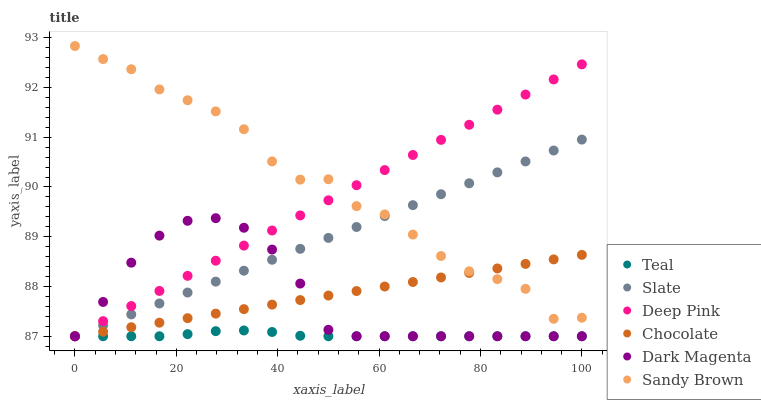Does Teal have the minimum area under the curve?
Answer yes or no. Yes. Does Sandy Brown have the maximum area under the curve?
Answer yes or no. Yes. Does Dark Magenta have the minimum area under the curve?
Answer yes or no. No. Does Dark Magenta have the maximum area under the curve?
Answer yes or no. No. Is Chocolate the smoothest?
Answer yes or no. Yes. Is Sandy Brown the roughest?
Answer yes or no. Yes. Is Dark Magenta the smoothest?
Answer yes or no. No. Is Dark Magenta the roughest?
Answer yes or no. No. Does Deep Pink have the lowest value?
Answer yes or no. Yes. Does Sandy Brown have the lowest value?
Answer yes or no. No. Does Sandy Brown have the highest value?
Answer yes or no. Yes. Does Dark Magenta have the highest value?
Answer yes or no. No. Is Teal less than Sandy Brown?
Answer yes or no. Yes. Is Sandy Brown greater than Dark Magenta?
Answer yes or no. Yes. Does Chocolate intersect Dark Magenta?
Answer yes or no. Yes. Is Chocolate less than Dark Magenta?
Answer yes or no. No. Is Chocolate greater than Dark Magenta?
Answer yes or no. No. Does Teal intersect Sandy Brown?
Answer yes or no. No. 